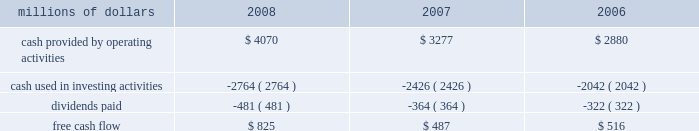Levels during 2008 , an indication that efforts to improve network operations translated into better customer service .
2022 fuel prices 2013 crude oil prices increased at a steady rate through the first seven months of 2008 , closing at a record high of $ 145.29 a barrel in early july .
As the economy worsened during the third and fourth quarters , fuel prices dropped dramatically , hitting $ 33.87 per barrel in december , a near five-year low .
Despite these price declines toward the end of the year , our 2008 average fuel price increased by 39% ( 39 % ) and added $ 1.1 billion of operating expenses compared to 2007 .
Our fuel surcharge programs helped offset the impact of higher fuel prices .
In addition , we reduced our consumption rate by 4% ( 4 % ) , saving approximately 58 million gallons of fuel during the year .
The use of newer , more fuel efficient locomotives ; our fuel conservation programs ; improved network operations ; and a shift in commodity mix , primarily due to growth in bulk shipments , contributed to the improvement .
2022 free cash flow 2013 cash generated by operating activities totaled a record $ 4.1 billion , yielding free cash flow of $ 825 million in 2008 .
Free cash flow is defined as cash provided by operating activities , less cash used in investing activities and dividends paid .
Free cash flow is not considered a financial measure under accounting principles generally accepted in the united states ( gaap ) by sec regulation g and item 10 of sec regulation s-k .
We believe free cash flow is important in evaluating our financial performance and measures our ability to generate cash without additional external financings .
Free cash flow should be considered in addition to , rather than as a substitute for , cash provided by operating activities .
The table reconciles cash provided by operating activities ( gaap measure ) to free cash flow ( non-gaap measure ) : millions of dollars 2008 2007 2006 .
2009 outlook 2022 safety 2013 operating a safe railroad benefits our employees , our customers , our shareholders , and the public .
We will continue using a multi-faceted approach to safety , utilizing technology , risk assessment , quality control , and training and engaging our employees .
We plan to continue implementation of total safety culture ( tsc ) throughout our operations .
Tsc , an employee-focused initiative that has helped improve safety , is a process designed to establish , maintain , and promote safety among co-workers .
With respect to public safety , we will continue our efforts to maintain , upgrade , and close crossings , install video cameras on locomotives , and educate the public about crossing safety through various railroad and industry programs , along with other activities .
2022 transportation plan 2013 in 2009 , we will continue to evaluate traffic flows and network logistic patterns to identify additional opportunities to simplify operations and improve network efficiency and asset utilization .
We plan to maintain adequate manpower and locomotives , and improve productivity using industrial engineering techniques .
2022 fuel prices 2013 on average , we expect fuel prices to decrease substantially from the average price we paid in 2008 .
However , due to economic uncertainty , other global pressures , and weather incidents , fuel prices again could be volatile during the year .
To reduce the impact of fuel price on earnings , we .
What was the percentage change in free cash flow from 2007 to 2008? 
Computations: ((825 - 487) / 487)
Answer: 0.69405. 